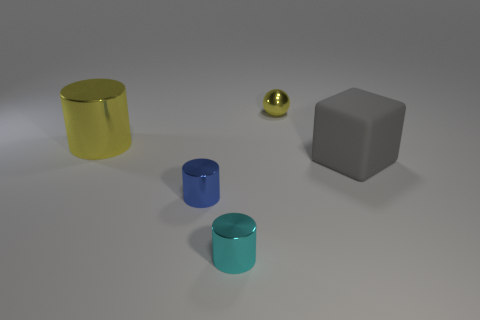Subtract all yellow cylinders. How many cylinders are left? 2 Subtract 3 cylinders. How many cylinders are left? 0 Add 4 small yellow objects. How many objects exist? 9 Subtract all cyan cylinders. How many cylinders are left? 2 Subtract all cylinders. How many objects are left? 2 Subtract all green cylinders. How many purple spheres are left? 0 Subtract all tiny purple spheres. Subtract all gray cubes. How many objects are left? 4 Add 1 matte blocks. How many matte blocks are left? 2 Add 4 tiny red shiny balls. How many tiny red shiny balls exist? 4 Subtract 0 blue balls. How many objects are left? 5 